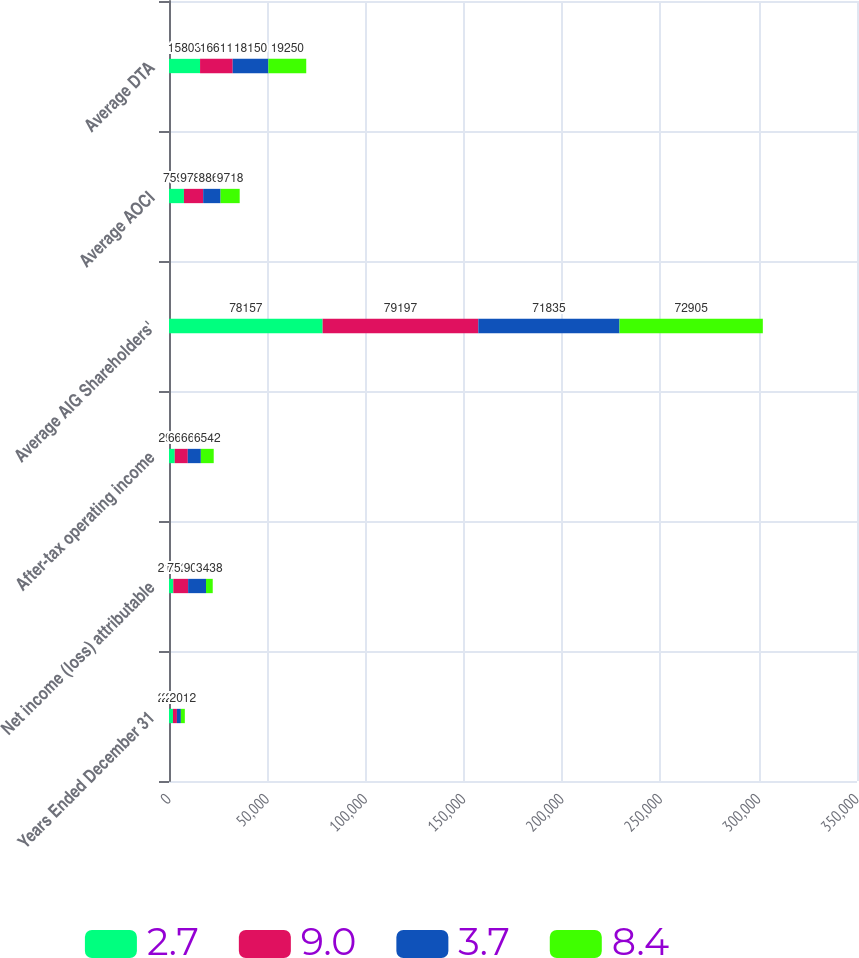Convert chart to OTSL. <chart><loc_0><loc_0><loc_500><loc_500><stacked_bar_chart><ecel><fcel>Years Ended December 31<fcel>Net income (loss) attributable<fcel>After-tax operating income<fcel>Average AIG Shareholders'<fcel>Average AOCI<fcel>Average DTA<nl><fcel>2.7<fcel>2015<fcel>2196<fcel>2927<fcel>78157<fcel>7598<fcel>15803<nl><fcel>9<fcel>2014<fcel>7529<fcel>6630<fcel>79197<fcel>9781<fcel>16611<nl><fcel>3.7<fcel>2013<fcel>9085<fcel>6650<fcel>71835<fcel>8865<fcel>18150<nl><fcel>8.4<fcel>2012<fcel>3438<fcel>6542<fcel>72905<fcel>9718<fcel>19250<nl></chart> 